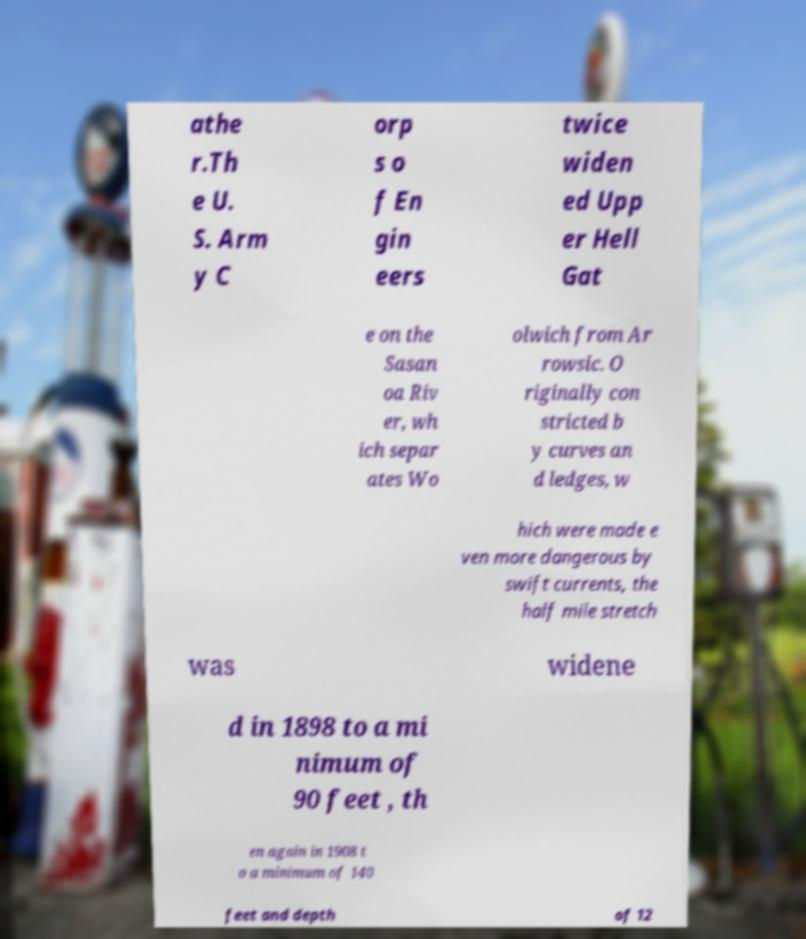I need the written content from this picture converted into text. Can you do that? athe r.Th e U. S. Arm y C orp s o f En gin eers twice widen ed Upp er Hell Gat e on the Sasan oa Riv er, wh ich separ ates Wo olwich from Ar rowsic. O riginally con stricted b y curves an d ledges, w hich were made e ven more dangerous by swift currents, the half mile stretch was widene d in 1898 to a mi nimum of 90 feet , th en again in 1908 t o a minimum of 140 feet and depth of 12 